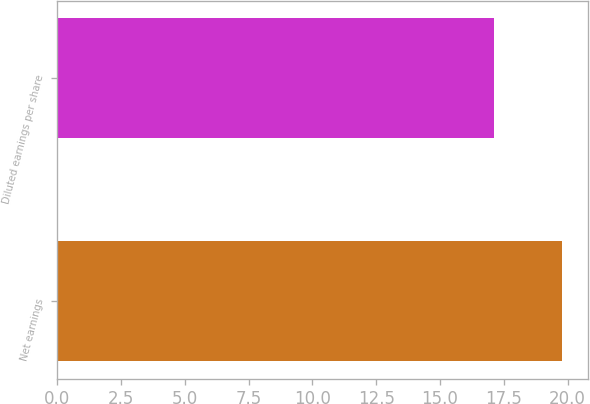Convert chart to OTSL. <chart><loc_0><loc_0><loc_500><loc_500><bar_chart><fcel>Net earnings<fcel>Diluted earnings per share<nl><fcel>19.8<fcel>17.1<nl></chart> 